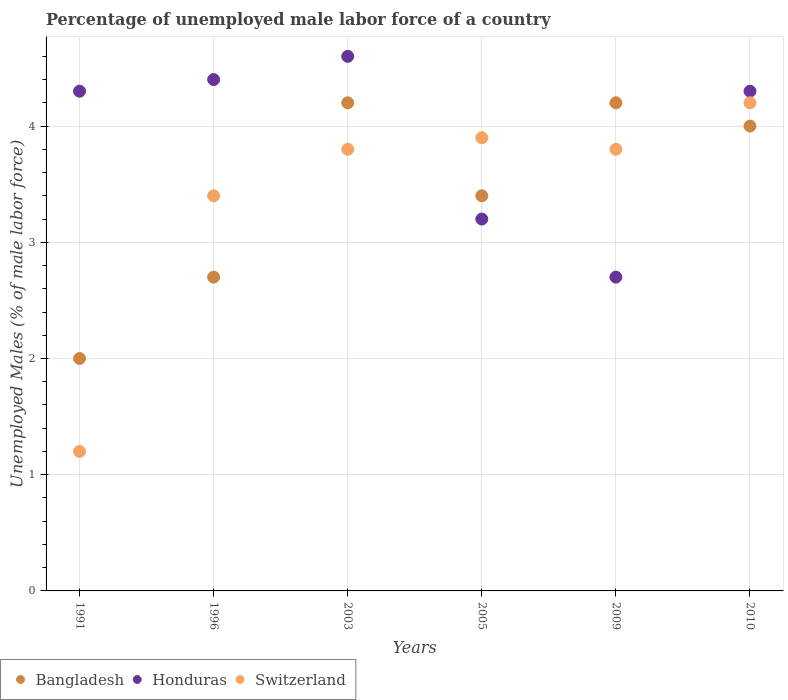What is the percentage of unemployed male labor force in Honduras in 1991?
Give a very brief answer. 4.3. Across all years, what is the maximum percentage of unemployed male labor force in Honduras?
Offer a very short reply. 4.6. Across all years, what is the minimum percentage of unemployed male labor force in Switzerland?
Offer a very short reply. 1.2. In which year was the percentage of unemployed male labor force in Bangladesh maximum?
Provide a succinct answer. 2003. What is the total percentage of unemployed male labor force in Bangladesh in the graph?
Give a very brief answer. 20.5. What is the difference between the percentage of unemployed male labor force in Bangladesh in 1991 and that in 2009?
Offer a very short reply. -2.2. What is the difference between the percentage of unemployed male labor force in Bangladesh in 2009 and the percentage of unemployed male labor force in Honduras in 2010?
Provide a short and direct response. -0.1. What is the average percentage of unemployed male labor force in Switzerland per year?
Your answer should be very brief. 3.38. In the year 2003, what is the difference between the percentage of unemployed male labor force in Honduras and percentage of unemployed male labor force in Switzerland?
Keep it short and to the point. 0.8. What is the ratio of the percentage of unemployed male labor force in Honduras in 1991 to that in 1996?
Your answer should be very brief. 0.98. Is the percentage of unemployed male labor force in Switzerland in 1996 less than that in 2009?
Your answer should be very brief. Yes. What is the difference between the highest and the second highest percentage of unemployed male labor force in Switzerland?
Your response must be concise. 0.3. What is the difference between the highest and the lowest percentage of unemployed male labor force in Bangladesh?
Make the answer very short. 2.2. In how many years, is the percentage of unemployed male labor force in Switzerland greater than the average percentage of unemployed male labor force in Switzerland taken over all years?
Offer a very short reply. 5. Is the sum of the percentage of unemployed male labor force in Honduras in 1996 and 2010 greater than the maximum percentage of unemployed male labor force in Bangladesh across all years?
Offer a very short reply. Yes. Does the percentage of unemployed male labor force in Bangladesh monotonically increase over the years?
Give a very brief answer. No. Is the percentage of unemployed male labor force in Bangladesh strictly less than the percentage of unemployed male labor force in Switzerland over the years?
Provide a short and direct response. No. Are the values on the major ticks of Y-axis written in scientific E-notation?
Give a very brief answer. No. Does the graph contain any zero values?
Your answer should be very brief. No. Does the graph contain grids?
Your answer should be very brief. Yes. Where does the legend appear in the graph?
Offer a terse response. Bottom left. How are the legend labels stacked?
Give a very brief answer. Horizontal. What is the title of the graph?
Your answer should be compact. Percentage of unemployed male labor force of a country. Does "Iceland" appear as one of the legend labels in the graph?
Your answer should be very brief. No. What is the label or title of the X-axis?
Give a very brief answer. Years. What is the label or title of the Y-axis?
Offer a very short reply. Unemployed Males (% of male labor force). What is the Unemployed Males (% of male labor force) of Bangladesh in 1991?
Provide a short and direct response. 2. What is the Unemployed Males (% of male labor force) in Honduras in 1991?
Your response must be concise. 4.3. What is the Unemployed Males (% of male labor force) of Switzerland in 1991?
Ensure brevity in your answer.  1.2. What is the Unemployed Males (% of male labor force) in Bangladesh in 1996?
Offer a terse response. 2.7. What is the Unemployed Males (% of male labor force) of Honduras in 1996?
Your answer should be very brief. 4.4. What is the Unemployed Males (% of male labor force) in Switzerland in 1996?
Your answer should be very brief. 3.4. What is the Unemployed Males (% of male labor force) in Bangladesh in 2003?
Provide a short and direct response. 4.2. What is the Unemployed Males (% of male labor force) of Honduras in 2003?
Keep it short and to the point. 4.6. What is the Unemployed Males (% of male labor force) in Switzerland in 2003?
Make the answer very short. 3.8. What is the Unemployed Males (% of male labor force) of Bangladesh in 2005?
Offer a terse response. 3.4. What is the Unemployed Males (% of male labor force) of Honduras in 2005?
Offer a very short reply. 3.2. What is the Unemployed Males (% of male labor force) of Switzerland in 2005?
Your answer should be compact. 3.9. What is the Unemployed Males (% of male labor force) of Bangladesh in 2009?
Offer a terse response. 4.2. What is the Unemployed Males (% of male labor force) of Honduras in 2009?
Keep it short and to the point. 2.7. What is the Unemployed Males (% of male labor force) of Switzerland in 2009?
Keep it short and to the point. 3.8. What is the Unemployed Males (% of male labor force) of Honduras in 2010?
Provide a short and direct response. 4.3. What is the Unemployed Males (% of male labor force) in Switzerland in 2010?
Provide a short and direct response. 4.2. Across all years, what is the maximum Unemployed Males (% of male labor force) in Bangladesh?
Provide a short and direct response. 4.2. Across all years, what is the maximum Unemployed Males (% of male labor force) in Honduras?
Offer a very short reply. 4.6. Across all years, what is the maximum Unemployed Males (% of male labor force) in Switzerland?
Provide a short and direct response. 4.2. Across all years, what is the minimum Unemployed Males (% of male labor force) of Honduras?
Give a very brief answer. 2.7. Across all years, what is the minimum Unemployed Males (% of male labor force) in Switzerland?
Provide a short and direct response. 1.2. What is the total Unemployed Males (% of male labor force) in Bangladesh in the graph?
Keep it short and to the point. 20.5. What is the total Unemployed Males (% of male labor force) in Honduras in the graph?
Ensure brevity in your answer.  23.5. What is the total Unemployed Males (% of male labor force) in Switzerland in the graph?
Offer a terse response. 20.3. What is the difference between the Unemployed Males (% of male labor force) in Bangladesh in 1991 and that in 1996?
Provide a succinct answer. -0.7. What is the difference between the Unemployed Males (% of male labor force) in Switzerland in 1991 and that in 1996?
Offer a terse response. -2.2. What is the difference between the Unemployed Males (% of male labor force) in Bangladesh in 1991 and that in 2003?
Provide a short and direct response. -2.2. What is the difference between the Unemployed Males (% of male labor force) of Switzerland in 1991 and that in 2003?
Your answer should be compact. -2.6. What is the difference between the Unemployed Males (% of male labor force) in Honduras in 1991 and that in 2005?
Keep it short and to the point. 1.1. What is the difference between the Unemployed Males (% of male labor force) of Bangladesh in 1991 and that in 2009?
Give a very brief answer. -2.2. What is the difference between the Unemployed Males (% of male labor force) in Switzerland in 1991 and that in 2009?
Ensure brevity in your answer.  -2.6. What is the difference between the Unemployed Males (% of male labor force) of Honduras in 1991 and that in 2010?
Your response must be concise. 0. What is the difference between the Unemployed Males (% of male labor force) of Honduras in 1996 and that in 2003?
Ensure brevity in your answer.  -0.2. What is the difference between the Unemployed Males (% of male labor force) in Switzerland in 1996 and that in 2003?
Offer a very short reply. -0.4. What is the difference between the Unemployed Males (% of male labor force) in Switzerland in 1996 and that in 2010?
Provide a succinct answer. -0.8. What is the difference between the Unemployed Males (% of male labor force) in Honduras in 2003 and that in 2005?
Your answer should be compact. 1.4. What is the difference between the Unemployed Males (% of male labor force) of Honduras in 2003 and that in 2010?
Provide a short and direct response. 0.3. What is the difference between the Unemployed Males (% of male labor force) in Honduras in 2005 and that in 2009?
Provide a succinct answer. 0.5. What is the difference between the Unemployed Males (% of male labor force) of Switzerland in 2005 and that in 2009?
Your answer should be very brief. 0.1. What is the difference between the Unemployed Males (% of male labor force) of Honduras in 2005 and that in 2010?
Offer a terse response. -1.1. What is the difference between the Unemployed Males (% of male labor force) of Honduras in 2009 and that in 2010?
Make the answer very short. -1.6. What is the difference between the Unemployed Males (% of male labor force) in Switzerland in 2009 and that in 2010?
Your answer should be compact. -0.4. What is the difference between the Unemployed Males (% of male labor force) of Bangladesh in 1991 and the Unemployed Males (% of male labor force) of Honduras in 1996?
Your answer should be very brief. -2.4. What is the difference between the Unemployed Males (% of male labor force) of Honduras in 1991 and the Unemployed Males (% of male labor force) of Switzerland in 1996?
Offer a very short reply. 0.9. What is the difference between the Unemployed Males (% of male labor force) of Bangladesh in 1991 and the Unemployed Males (% of male labor force) of Switzerland in 2003?
Offer a very short reply. -1.8. What is the difference between the Unemployed Males (% of male labor force) in Bangladesh in 1991 and the Unemployed Males (% of male labor force) in Switzerland in 2005?
Keep it short and to the point. -1.9. What is the difference between the Unemployed Males (% of male labor force) in Bangladesh in 1991 and the Unemployed Males (% of male labor force) in Honduras in 2010?
Keep it short and to the point. -2.3. What is the difference between the Unemployed Males (% of male labor force) of Honduras in 1991 and the Unemployed Males (% of male labor force) of Switzerland in 2010?
Provide a short and direct response. 0.1. What is the difference between the Unemployed Males (% of male labor force) in Bangladesh in 1996 and the Unemployed Males (% of male labor force) in Switzerland in 2003?
Provide a short and direct response. -1.1. What is the difference between the Unemployed Males (% of male labor force) in Honduras in 1996 and the Unemployed Males (% of male labor force) in Switzerland in 2003?
Offer a terse response. 0.6. What is the difference between the Unemployed Males (% of male labor force) in Bangladesh in 1996 and the Unemployed Males (% of male labor force) in Honduras in 2005?
Offer a very short reply. -0.5. What is the difference between the Unemployed Males (% of male labor force) of Bangladesh in 1996 and the Unemployed Males (% of male labor force) of Switzerland in 2005?
Make the answer very short. -1.2. What is the difference between the Unemployed Males (% of male labor force) in Bangladesh in 1996 and the Unemployed Males (% of male labor force) in Honduras in 2009?
Your answer should be compact. 0. What is the difference between the Unemployed Males (% of male labor force) in Honduras in 1996 and the Unemployed Males (% of male labor force) in Switzerland in 2009?
Your response must be concise. 0.6. What is the difference between the Unemployed Males (% of male labor force) of Bangladesh in 1996 and the Unemployed Males (% of male labor force) of Honduras in 2010?
Provide a succinct answer. -1.6. What is the difference between the Unemployed Males (% of male labor force) in Bangladesh in 1996 and the Unemployed Males (% of male labor force) in Switzerland in 2010?
Your answer should be very brief. -1.5. What is the difference between the Unemployed Males (% of male labor force) in Bangladesh in 2003 and the Unemployed Males (% of male labor force) in Honduras in 2005?
Offer a very short reply. 1. What is the difference between the Unemployed Males (% of male labor force) in Bangladesh in 2003 and the Unemployed Males (% of male labor force) in Switzerland in 2009?
Provide a short and direct response. 0.4. What is the difference between the Unemployed Males (% of male labor force) in Honduras in 2003 and the Unemployed Males (% of male labor force) in Switzerland in 2009?
Make the answer very short. 0.8. What is the difference between the Unemployed Males (% of male labor force) in Bangladesh in 2005 and the Unemployed Males (% of male labor force) in Switzerland in 2009?
Your answer should be compact. -0.4. What is the difference between the Unemployed Males (% of male labor force) in Honduras in 2005 and the Unemployed Males (% of male labor force) in Switzerland in 2009?
Offer a terse response. -0.6. What is the difference between the Unemployed Males (% of male labor force) of Honduras in 2005 and the Unemployed Males (% of male labor force) of Switzerland in 2010?
Provide a succinct answer. -1. What is the difference between the Unemployed Males (% of male labor force) of Bangladesh in 2009 and the Unemployed Males (% of male labor force) of Switzerland in 2010?
Keep it short and to the point. 0. What is the difference between the Unemployed Males (% of male labor force) of Honduras in 2009 and the Unemployed Males (% of male labor force) of Switzerland in 2010?
Make the answer very short. -1.5. What is the average Unemployed Males (% of male labor force) of Bangladesh per year?
Provide a short and direct response. 3.42. What is the average Unemployed Males (% of male labor force) of Honduras per year?
Keep it short and to the point. 3.92. What is the average Unemployed Males (% of male labor force) in Switzerland per year?
Your answer should be compact. 3.38. In the year 1991, what is the difference between the Unemployed Males (% of male labor force) in Bangladesh and Unemployed Males (% of male labor force) in Honduras?
Offer a terse response. -2.3. In the year 1991, what is the difference between the Unemployed Males (% of male labor force) of Bangladesh and Unemployed Males (% of male labor force) of Switzerland?
Offer a terse response. 0.8. In the year 1991, what is the difference between the Unemployed Males (% of male labor force) of Honduras and Unemployed Males (% of male labor force) of Switzerland?
Give a very brief answer. 3.1. In the year 1996, what is the difference between the Unemployed Males (% of male labor force) of Bangladesh and Unemployed Males (% of male labor force) of Honduras?
Keep it short and to the point. -1.7. In the year 1996, what is the difference between the Unemployed Males (% of male labor force) in Honduras and Unemployed Males (% of male labor force) in Switzerland?
Offer a terse response. 1. In the year 2003, what is the difference between the Unemployed Males (% of male labor force) in Bangladesh and Unemployed Males (% of male labor force) in Switzerland?
Keep it short and to the point. 0.4. In the year 2005, what is the difference between the Unemployed Males (% of male labor force) of Bangladesh and Unemployed Males (% of male labor force) of Switzerland?
Provide a short and direct response. -0.5. In the year 2005, what is the difference between the Unemployed Males (% of male labor force) in Honduras and Unemployed Males (% of male labor force) in Switzerland?
Your response must be concise. -0.7. In the year 2009, what is the difference between the Unemployed Males (% of male labor force) of Bangladesh and Unemployed Males (% of male labor force) of Honduras?
Ensure brevity in your answer.  1.5. In the year 2009, what is the difference between the Unemployed Males (% of male labor force) of Honduras and Unemployed Males (% of male labor force) of Switzerland?
Provide a succinct answer. -1.1. In the year 2010, what is the difference between the Unemployed Males (% of male labor force) in Honduras and Unemployed Males (% of male labor force) in Switzerland?
Your answer should be compact. 0.1. What is the ratio of the Unemployed Males (% of male labor force) of Bangladesh in 1991 to that in 1996?
Keep it short and to the point. 0.74. What is the ratio of the Unemployed Males (% of male labor force) of Honduras in 1991 to that in 1996?
Give a very brief answer. 0.98. What is the ratio of the Unemployed Males (% of male labor force) of Switzerland in 1991 to that in 1996?
Provide a short and direct response. 0.35. What is the ratio of the Unemployed Males (% of male labor force) in Bangladesh in 1991 to that in 2003?
Your answer should be compact. 0.48. What is the ratio of the Unemployed Males (% of male labor force) in Honduras in 1991 to that in 2003?
Make the answer very short. 0.93. What is the ratio of the Unemployed Males (% of male labor force) in Switzerland in 1991 to that in 2003?
Offer a very short reply. 0.32. What is the ratio of the Unemployed Males (% of male labor force) of Bangladesh in 1991 to that in 2005?
Give a very brief answer. 0.59. What is the ratio of the Unemployed Males (% of male labor force) in Honduras in 1991 to that in 2005?
Your answer should be very brief. 1.34. What is the ratio of the Unemployed Males (% of male labor force) in Switzerland in 1991 to that in 2005?
Ensure brevity in your answer.  0.31. What is the ratio of the Unemployed Males (% of male labor force) in Bangladesh in 1991 to that in 2009?
Ensure brevity in your answer.  0.48. What is the ratio of the Unemployed Males (% of male labor force) of Honduras in 1991 to that in 2009?
Your response must be concise. 1.59. What is the ratio of the Unemployed Males (% of male labor force) of Switzerland in 1991 to that in 2009?
Offer a very short reply. 0.32. What is the ratio of the Unemployed Males (% of male labor force) of Honduras in 1991 to that in 2010?
Your response must be concise. 1. What is the ratio of the Unemployed Males (% of male labor force) of Switzerland in 1991 to that in 2010?
Give a very brief answer. 0.29. What is the ratio of the Unemployed Males (% of male labor force) in Bangladesh in 1996 to that in 2003?
Offer a terse response. 0.64. What is the ratio of the Unemployed Males (% of male labor force) of Honduras in 1996 to that in 2003?
Offer a terse response. 0.96. What is the ratio of the Unemployed Males (% of male labor force) in Switzerland in 1996 to that in 2003?
Make the answer very short. 0.89. What is the ratio of the Unemployed Males (% of male labor force) of Bangladesh in 1996 to that in 2005?
Provide a succinct answer. 0.79. What is the ratio of the Unemployed Males (% of male labor force) in Honduras in 1996 to that in 2005?
Provide a succinct answer. 1.38. What is the ratio of the Unemployed Males (% of male labor force) in Switzerland in 1996 to that in 2005?
Your answer should be very brief. 0.87. What is the ratio of the Unemployed Males (% of male labor force) of Bangladesh in 1996 to that in 2009?
Provide a succinct answer. 0.64. What is the ratio of the Unemployed Males (% of male labor force) in Honduras in 1996 to that in 2009?
Keep it short and to the point. 1.63. What is the ratio of the Unemployed Males (% of male labor force) of Switzerland in 1996 to that in 2009?
Make the answer very short. 0.89. What is the ratio of the Unemployed Males (% of male labor force) in Bangladesh in 1996 to that in 2010?
Keep it short and to the point. 0.68. What is the ratio of the Unemployed Males (% of male labor force) of Honduras in 1996 to that in 2010?
Your response must be concise. 1.02. What is the ratio of the Unemployed Males (% of male labor force) in Switzerland in 1996 to that in 2010?
Ensure brevity in your answer.  0.81. What is the ratio of the Unemployed Males (% of male labor force) in Bangladesh in 2003 to that in 2005?
Provide a succinct answer. 1.24. What is the ratio of the Unemployed Males (% of male labor force) of Honduras in 2003 to that in 2005?
Give a very brief answer. 1.44. What is the ratio of the Unemployed Males (% of male labor force) of Switzerland in 2003 to that in 2005?
Your answer should be very brief. 0.97. What is the ratio of the Unemployed Males (% of male labor force) in Honduras in 2003 to that in 2009?
Give a very brief answer. 1.7. What is the ratio of the Unemployed Males (% of male labor force) of Switzerland in 2003 to that in 2009?
Provide a short and direct response. 1. What is the ratio of the Unemployed Males (% of male labor force) in Honduras in 2003 to that in 2010?
Your answer should be very brief. 1.07. What is the ratio of the Unemployed Males (% of male labor force) in Switzerland in 2003 to that in 2010?
Provide a short and direct response. 0.9. What is the ratio of the Unemployed Males (% of male labor force) in Bangladesh in 2005 to that in 2009?
Your response must be concise. 0.81. What is the ratio of the Unemployed Males (% of male labor force) in Honduras in 2005 to that in 2009?
Keep it short and to the point. 1.19. What is the ratio of the Unemployed Males (% of male labor force) of Switzerland in 2005 to that in 2009?
Offer a very short reply. 1.03. What is the ratio of the Unemployed Males (% of male labor force) in Bangladesh in 2005 to that in 2010?
Offer a very short reply. 0.85. What is the ratio of the Unemployed Males (% of male labor force) in Honduras in 2005 to that in 2010?
Ensure brevity in your answer.  0.74. What is the ratio of the Unemployed Males (% of male labor force) of Bangladesh in 2009 to that in 2010?
Provide a short and direct response. 1.05. What is the ratio of the Unemployed Males (% of male labor force) of Honduras in 2009 to that in 2010?
Make the answer very short. 0.63. What is the ratio of the Unemployed Males (% of male labor force) of Switzerland in 2009 to that in 2010?
Provide a succinct answer. 0.9. What is the difference between the highest and the second highest Unemployed Males (% of male labor force) in Bangladesh?
Ensure brevity in your answer.  0. What is the difference between the highest and the second highest Unemployed Males (% of male labor force) of Honduras?
Offer a terse response. 0.2. What is the difference between the highest and the lowest Unemployed Males (% of male labor force) of Switzerland?
Your answer should be very brief. 3. 